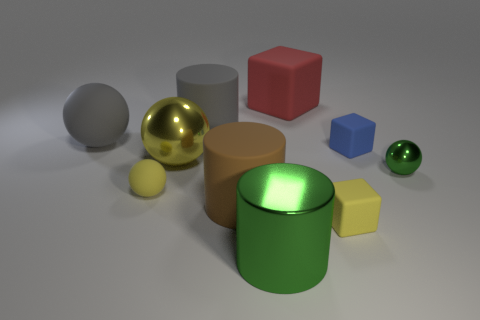Is there any other thing that is the same size as the yellow matte sphere?
Ensure brevity in your answer.  Yes. Is the number of small green objects right of the large matte sphere less than the number of yellow blocks?
Your answer should be very brief. No. Does the big red thing have the same shape as the tiny blue rubber thing?
Make the answer very short. Yes. There is another tiny matte thing that is the same shape as the blue object; what is its color?
Offer a terse response. Yellow. What number of tiny cubes are the same color as the large rubber block?
Offer a very short reply. 0. How many things are either gray things on the right side of the big yellow ball or spheres?
Offer a very short reply. 5. How big is the gray thing that is left of the tiny yellow sphere?
Offer a terse response. Large. Are there fewer tiny green things than small gray metallic balls?
Provide a succinct answer. No. Is the material of the tiny sphere on the right side of the big gray matte cylinder the same as the small yellow thing left of the yellow cube?
Your response must be concise. No. What shape is the small matte thing behind the green shiny object that is right of the tiny blue cube that is right of the brown cylinder?
Make the answer very short. Cube. 